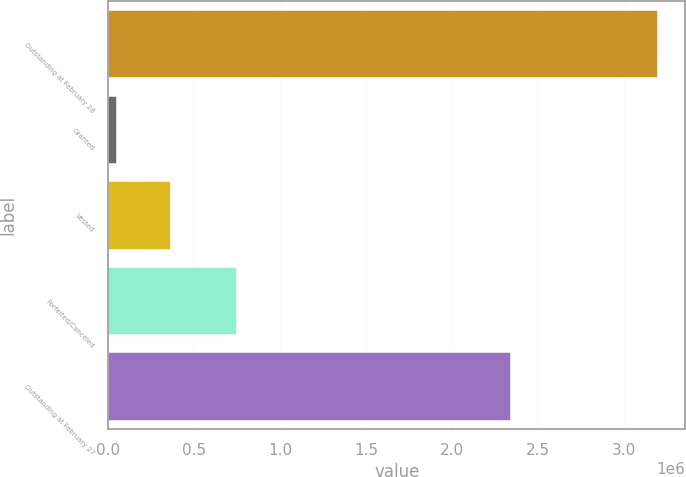Convert chart. <chart><loc_0><loc_0><loc_500><loc_500><bar_chart><fcel>Outstanding at February 28<fcel>Granted<fcel>Vested<fcel>Forfeited/Canceled<fcel>Outstanding at February 27<nl><fcel>3.198e+06<fcel>50000<fcel>364800<fcel>749000<fcel>2.343e+06<nl></chart> 